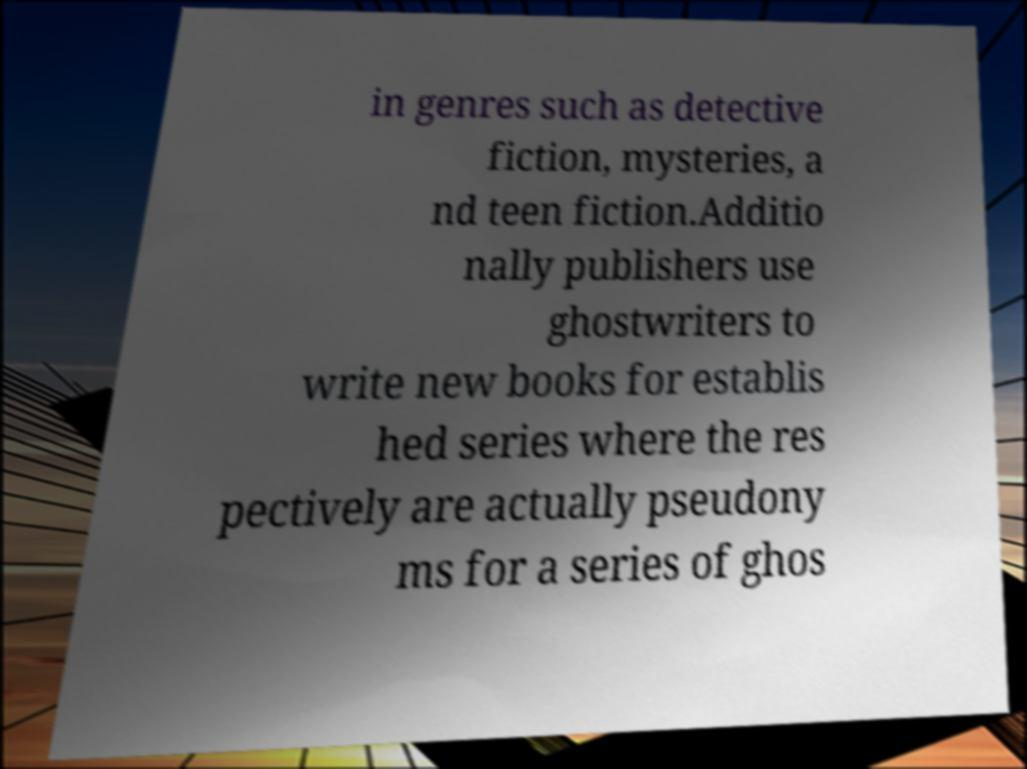Could you assist in decoding the text presented in this image and type it out clearly? in genres such as detective fiction, mysteries, a nd teen fiction.Additio nally publishers use ghostwriters to write new books for establis hed series where the res pectively are actually pseudony ms for a series of ghos 